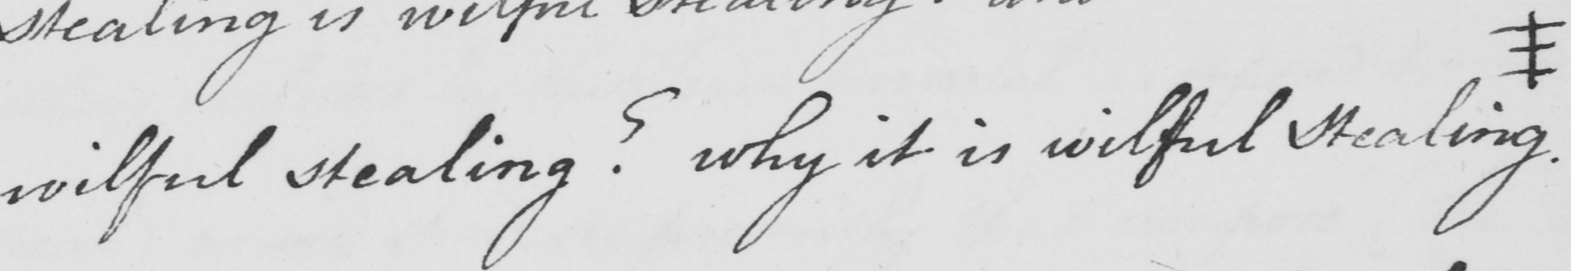What is written in this line of handwriting? wilful stealing ?  why it is wilful stealing # 